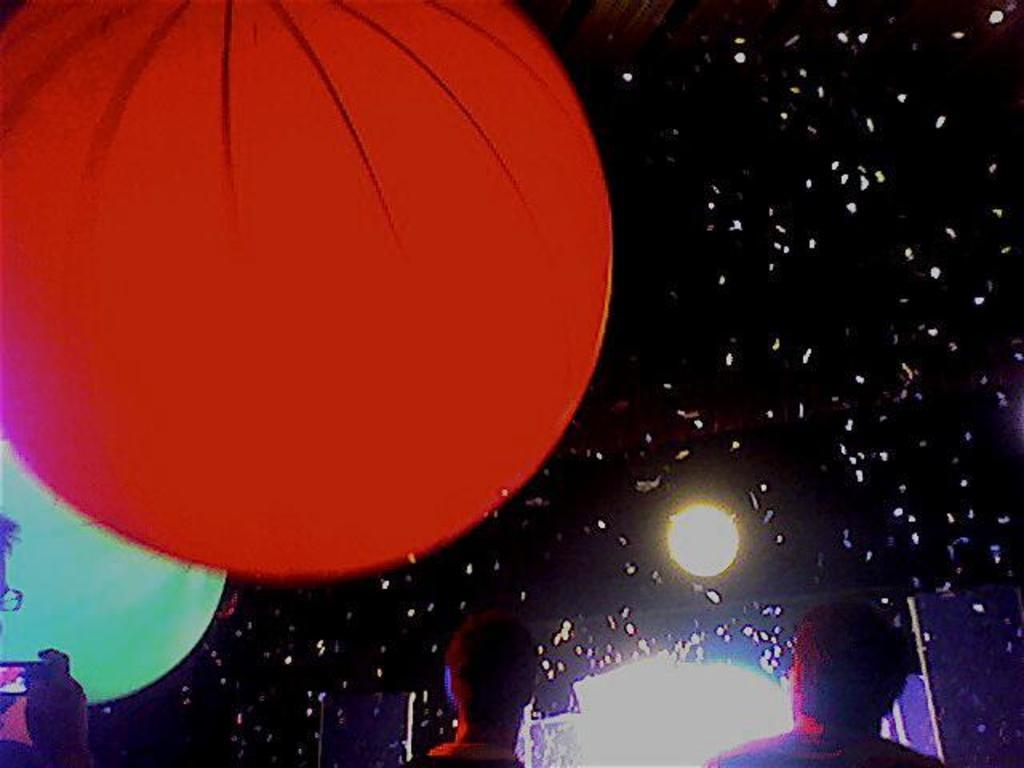Who or what can be seen at the bottom of the image? There are people at the bottom of the image. What is located on the left side of the image? There are big balloons on the left side of the image. Can you describe the background of the image? There is a light in the background of the image, and fireworks are visible in the air. What type of brush is being used to paint the idea in the image? There is no brush or idea present in the image; it features people, big balloons, a light, and fireworks. Can you see a stick being used by any of the people in the image? There is no stick visible in the image. 